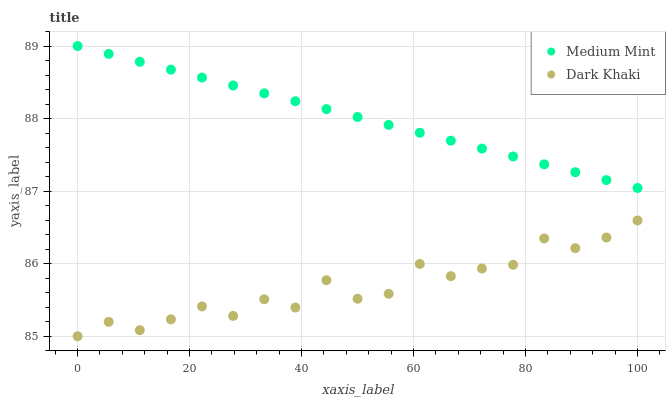Does Dark Khaki have the minimum area under the curve?
Answer yes or no. Yes. Does Medium Mint have the maximum area under the curve?
Answer yes or no. Yes. Does Dark Khaki have the maximum area under the curve?
Answer yes or no. No. Is Medium Mint the smoothest?
Answer yes or no. Yes. Is Dark Khaki the roughest?
Answer yes or no. Yes. Is Dark Khaki the smoothest?
Answer yes or no. No. Does Dark Khaki have the lowest value?
Answer yes or no. Yes. Does Medium Mint have the highest value?
Answer yes or no. Yes. Does Dark Khaki have the highest value?
Answer yes or no. No. Is Dark Khaki less than Medium Mint?
Answer yes or no. Yes. Is Medium Mint greater than Dark Khaki?
Answer yes or no. Yes. Does Dark Khaki intersect Medium Mint?
Answer yes or no. No. 